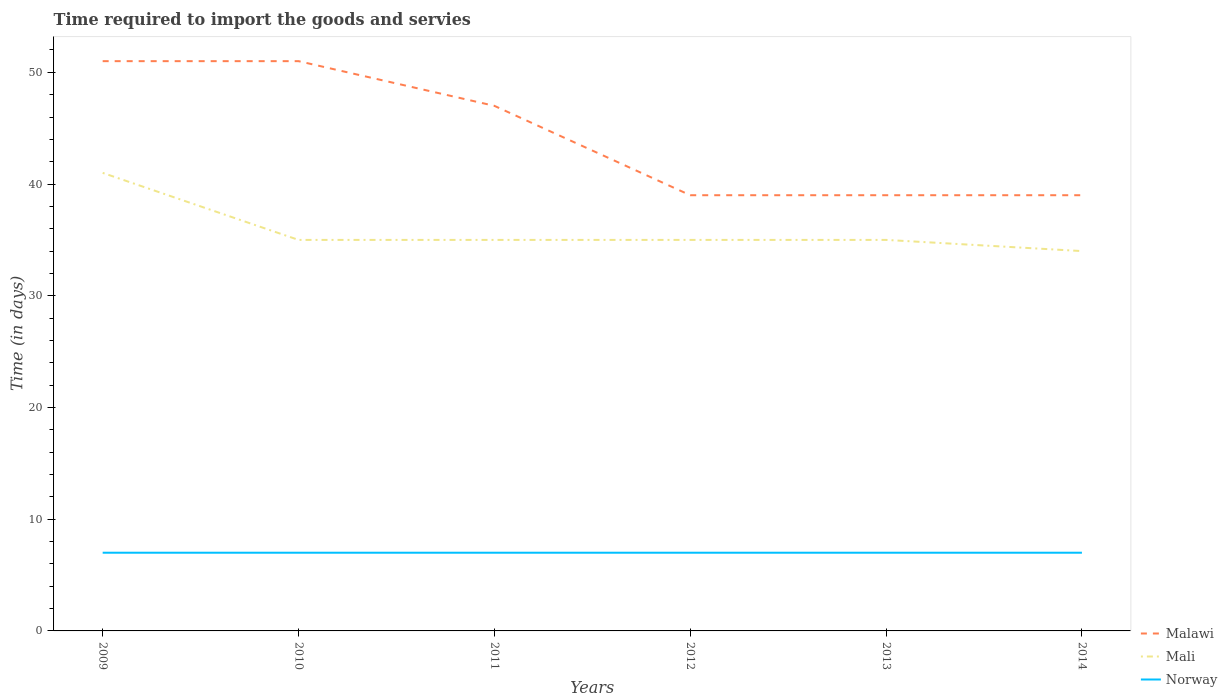Is the number of lines equal to the number of legend labels?
Your response must be concise. Yes. Across all years, what is the maximum number of days required to import the goods and services in Malawi?
Offer a terse response. 39. In which year was the number of days required to import the goods and services in Norway maximum?
Provide a short and direct response. 2009. What is the total number of days required to import the goods and services in Mali in the graph?
Make the answer very short. 1. What is the difference between the highest and the second highest number of days required to import the goods and services in Mali?
Your answer should be very brief. 7. What is the difference between the highest and the lowest number of days required to import the goods and services in Mali?
Ensure brevity in your answer.  1. How many years are there in the graph?
Provide a short and direct response. 6. Are the values on the major ticks of Y-axis written in scientific E-notation?
Make the answer very short. No. Does the graph contain any zero values?
Offer a very short reply. No. Where does the legend appear in the graph?
Keep it short and to the point. Bottom right. How many legend labels are there?
Your response must be concise. 3. How are the legend labels stacked?
Ensure brevity in your answer.  Vertical. What is the title of the graph?
Make the answer very short. Time required to import the goods and servies. What is the label or title of the X-axis?
Your answer should be very brief. Years. What is the label or title of the Y-axis?
Provide a short and direct response. Time (in days). What is the Time (in days) of Malawi in 2009?
Provide a short and direct response. 51. What is the Time (in days) of Mali in 2009?
Offer a very short reply. 41. What is the Time (in days) of Norway in 2009?
Make the answer very short. 7. What is the Time (in days) in Mali in 2010?
Provide a short and direct response. 35. What is the Time (in days) in Norway in 2010?
Offer a terse response. 7. What is the Time (in days) of Malawi in 2012?
Ensure brevity in your answer.  39. What is the Time (in days) of Mali in 2012?
Give a very brief answer. 35. What is the Time (in days) in Norway in 2012?
Your response must be concise. 7. What is the Time (in days) of Malawi in 2013?
Ensure brevity in your answer.  39. What is the Time (in days) of Mali in 2013?
Provide a succinct answer. 35. What is the Time (in days) in Norway in 2013?
Give a very brief answer. 7. What is the Time (in days) of Mali in 2014?
Provide a short and direct response. 34. What is the Time (in days) in Norway in 2014?
Offer a terse response. 7. Across all years, what is the maximum Time (in days) of Norway?
Keep it short and to the point. 7. Across all years, what is the minimum Time (in days) of Malawi?
Ensure brevity in your answer.  39. Across all years, what is the minimum Time (in days) of Mali?
Your response must be concise. 34. What is the total Time (in days) of Malawi in the graph?
Your response must be concise. 266. What is the total Time (in days) of Mali in the graph?
Offer a very short reply. 215. What is the difference between the Time (in days) in Norway in 2009 and that in 2010?
Provide a succinct answer. 0. What is the difference between the Time (in days) of Malawi in 2009 and that in 2011?
Your answer should be very brief. 4. What is the difference between the Time (in days) of Mali in 2009 and that in 2011?
Keep it short and to the point. 6. What is the difference between the Time (in days) of Malawi in 2009 and that in 2012?
Provide a succinct answer. 12. What is the difference between the Time (in days) in Mali in 2009 and that in 2012?
Give a very brief answer. 6. What is the difference between the Time (in days) of Malawi in 2009 and that in 2013?
Keep it short and to the point. 12. What is the difference between the Time (in days) in Mali in 2009 and that in 2013?
Provide a short and direct response. 6. What is the difference between the Time (in days) of Norway in 2009 and that in 2013?
Provide a succinct answer. 0. What is the difference between the Time (in days) in Norway in 2009 and that in 2014?
Your answer should be compact. 0. What is the difference between the Time (in days) of Norway in 2010 and that in 2012?
Your answer should be compact. 0. What is the difference between the Time (in days) in Malawi in 2010 and that in 2013?
Make the answer very short. 12. What is the difference between the Time (in days) in Norway in 2010 and that in 2013?
Your response must be concise. 0. What is the difference between the Time (in days) in Mali in 2010 and that in 2014?
Give a very brief answer. 1. What is the difference between the Time (in days) of Norway in 2010 and that in 2014?
Your answer should be compact. 0. What is the difference between the Time (in days) of Malawi in 2011 and that in 2012?
Keep it short and to the point. 8. What is the difference between the Time (in days) in Mali in 2011 and that in 2012?
Offer a very short reply. 0. What is the difference between the Time (in days) in Norway in 2011 and that in 2012?
Offer a very short reply. 0. What is the difference between the Time (in days) in Norway in 2011 and that in 2013?
Keep it short and to the point. 0. What is the difference between the Time (in days) of Mali in 2011 and that in 2014?
Ensure brevity in your answer.  1. What is the difference between the Time (in days) of Norway in 2011 and that in 2014?
Your response must be concise. 0. What is the difference between the Time (in days) in Mali in 2012 and that in 2013?
Your answer should be compact. 0. What is the difference between the Time (in days) of Malawi in 2013 and that in 2014?
Give a very brief answer. 0. What is the difference between the Time (in days) in Mali in 2013 and that in 2014?
Provide a short and direct response. 1. What is the difference between the Time (in days) in Norway in 2013 and that in 2014?
Give a very brief answer. 0. What is the difference between the Time (in days) of Malawi in 2009 and the Time (in days) of Norway in 2010?
Make the answer very short. 44. What is the difference between the Time (in days) in Mali in 2009 and the Time (in days) in Norway in 2010?
Keep it short and to the point. 34. What is the difference between the Time (in days) in Mali in 2009 and the Time (in days) in Norway in 2011?
Give a very brief answer. 34. What is the difference between the Time (in days) of Malawi in 2009 and the Time (in days) of Norway in 2012?
Keep it short and to the point. 44. What is the difference between the Time (in days) in Malawi in 2009 and the Time (in days) in Norway in 2013?
Provide a succinct answer. 44. What is the difference between the Time (in days) in Mali in 2009 and the Time (in days) in Norway in 2013?
Your answer should be compact. 34. What is the difference between the Time (in days) in Malawi in 2009 and the Time (in days) in Mali in 2014?
Provide a succinct answer. 17. What is the difference between the Time (in days) in Malawi in 2009 and the Time (in days) in Norway in 2014?
Make the answer very short. 44. What is the difference between the Time (in days) in Mali in 2009 and the Time (in days) in Norway in 2014?
Offer a terse response. 34. What is the difference between the Time (in days) in Malawi in 2010 and the Time (in days) in Mali in 2011?
Your response must be concise. 16. What is the difference between the Time (in days) in Malawi in 2010 and the Time (in days) in Mali in 2012?
Keep it short and to the point. 16. What is the difference between the Time (in days) of Malawi in 2010 and the Time (in days) of Norway in 2012?
Give a very brief answer. 44. What is the difference between the Time (in days) in Malawi in 2010 and the Time (in days) in Norway in 2013?
Offer a very short reply. 44. What is the difference between the Time (in days) of Malawi in 2010 and the Time (in days) of Mali in 2014?
Your answer should be very brief. 17. What is the difference between the Time (in days) in Malawi in 2010 and the Time (in days) in Norway in 2014?
Your answer should be compact. 44. What is the difference between the Time (in days) of Mali in 2010 and the Time (in days) of Norway in 2014?
Your answer should be compact. 28. What is the difference between the Time (in days) in Malawi in 2011 and the Time (in days) in Norway in 2012?
Your answer should be compact. 40. What is the difference between the Time (in days) in Mali in 2011 and the Time (in days) in Norway in 2013?
Your answer should be very brief. 28. What is the difference between the Time (in days) in Malawi in 2012 and the Time (in days) in Mali in 2013?
Your answer should be compact. 4. What is the difference between the Time (in days) of Malawi in 2012 and the Time (in days) of Norway in 2013?
Provide a short and direct response. 32. What is the difference between the Time (in days) in Malawi in 2012 and the Time (in days) in Norway in 2014?
Offer a very short reply. 32. What is the difference between the Time (in days) of Malawi in 2013 and the Time (in days) of Mali in 2014?
Offer a very short reply. 5. What is the difference between the Time (in days) in Malawi in 2013 and the Time (in days) in Norway in 2014?
Keep it short and to the point. 32. What is the difference between the Time (in days) in Mali in 2013 and the Time (in days) in Norway in 2014?
Give a very brief answer. 28. What is the average Time (in days) of Malawi per year?
Your answer should be compact. 44.33. What is the average Time (in days) in Mali per year?
Ensure brevity in your answer.  35.83. What is the average Time (in days) of Norway per year?
Give a very brief answer. 7. In the year 2009, what is the difference between the Time (in days) in Mali and Time (in days) in Norway?
Offer a very short reply. 34. In the year 2010, what is the difference between the Time (in days) in Malawi and Time (in days) in Norway?
Your answer should be very brief. 44. In the year 2010, what is the difference between the Time (in days) of Mali and Time (in days) of Norway?
Give a very brief answer. 28. In the year 2011, what is the difference between the Time (in days) in Malawi and Time (in days) in Norway?
Offer a very short reply. 40. In the year 2011, what is the difference between the Time (in days) in Mali and Time (in days) in Norway?
Your answer should be compact. 28. In the year 2012, what is the difference between the Time (in days) in Malawi and Time (in days) in Mali?
Keep it short and to the point. 4. In the year 2012, what is the difference between the Time (in days) of Mali and Time (in days) of Norway?
Keep it short and to the point. 28. In the year 2013, what is the difference between the Time (in days) in Malawi and Time (in days) in Mali?
Offer a terse response. 4. In the year 2013, what is the difference between the Time (in days) in Malawi and Time (in days) in Norway?
Provide a succinct answer. 32. In the year 2013, what is the difference between the Time (in days) of Mali and Time (in days) of Norway?
Provide a short and direct response. 28. In the year 2014, what is the difference between the Time (in days) of Malawi and Time (in days) of Mali?
Ensure brevity in your answer.  5. In the year 2014, what is the difference between the Time (in days) of Malawi and Time (in days) of Norway?
Make the answer very short. 32. What is the ratio of the Time (in days) of Malawi in 2009 to that in 2010?
Your answer should be compact. 1. What is the ratio of the Time (in days) of Mali in 2009 to that in 2010?
Offer a very short reply. 1.17. What is the ratio of the Time (in days) in Norway in 2009 to that in 2010?
Offer a terse response. 1. What is the ratio of the Time (in days) in Malawi in 2009 to that in 2011?
Offer a terse response. 1.09. What is the ratio of the Time (in days) in Mali in 2009 to that in 2011?
Provide a succinct answer. 1.17. What is the ratio of the Time (in days) in Norway in 2009 to that in 2011?
Keep it short and to the point. 1. What is the ratio of the Time (in days) in Malawi in 2009 to that in 2012?
Give a very brief answer. 1.31. What is the ratio of the Time (in days) of Mali in 2009 to that in 2012?
Your answer should be compact. 1.17. What is the ratio of the Time (in days) of Malawi in 2009 to that in 2013?
Make the answer very short. 1.31. What is the ratio of the Time (in days) of Mali in 2009 to that in 2013?
Keep it short and to the point. 1.17. What is the ratio of the Time (in days) in Malawi in 2009 to that in 2014?
Ensure brevity in your answer.  1.31. What is the ratio of the Time (in days) in Mali in 2009 to that in 2014?
Give a very brief answer. 1.21. What is the ratio of the Time (in days) of Norway in 2009 to that in 2014?
Your answer should be compact. 1. What is the ratio of the Time (in days) of Malawi in 2010 to that in 2011?
Provide a succinct answer. 1.09. What is the ratio of the Time (in days) of Mali in 2010 to that in 2011?
Offer a very short reply. 1. What is the ratio of the Time (in days) of Norway in 2010 to that in 2011?
Keep it short and to the point. 1. What is the ratio of the Time (in days) in Malawi in 2010 to that in 2012?
Provide a short and direct response. 1.31. What is the ratio of the Time (in days) of Mali in 2010 to that in 2012?
Offer a terse response. 1. What is the ratio of the Time (in days) of Norway in 2010 to that in 2012?
Give a very brief answer. 1. What is the ratio of the Time (in days) of Malawi in 2010 to that in 2013?
Make the answer very short. 1.31. What is the ratio of the Time (in days) in Mali in 2010 to that in 2013?
Offer a terse response. 1. What is the ratio of the Time (in days) of Malawi in 2010 to that in 2014?
Provide a short and direct response. 1.31. What is the ratio of the Time (in days) in Mali in 2010 to that in 2014?
Offer a terse response. 1.03. What is the ratio of the Time (in days) of Malawi in 2011 to that in 2012?
Provide a succinct answer. 1.21. What is the ratio of the Time (in days) of Mali in 2011 to that in 2012?
Give a very brief answer. 1. What is the ratio of the Time (in days) of Malawi in 2011 to that in 2013?
Your answer should be compact. 1.21. What is the ratio of the Time (in days) of Mali in 2011 to that in 2013?
Your answer should be very brief. 1. What is the ratio of the Time (in days) in Norway in 2011 to that in 2013?
Offer a very short reply. 1. What is the ratio of the Time (in days) of Malawi in 2011 to that in 2014?
Offer a very short reply. 1.21. What is the ratio of the Time (in days) in Mali in 2011 to that in 2014?
Offer a terse response. 1.03. What is the ratio of the Time (in days) in Norway in 2011 to that in 2014?
Provide a short and direct response. 1. What is the ratio of the Time (in days) of Mali in 2012 to that in 2014?
Give a very brief answer. 1.03. What is the ratio of the Time (in days) of Norway in 2012 to that in 2014?
Offer a terse response. 1. What is the ratio of the Time (in days) in Mali in 2013 to that in 2014?
Give a very brief answer. 1.03. What is the difference between the highest and the second highest Time (in days) in Malawi?
Provide a succinct answer. 0. What is the difference between the highest and the lowest Time (in days) in Malawi?
Keep it short and to the point. 12. What is the difference between the highest and the lowest Time (in days) of Mali?
Your response must be concise. 7. 